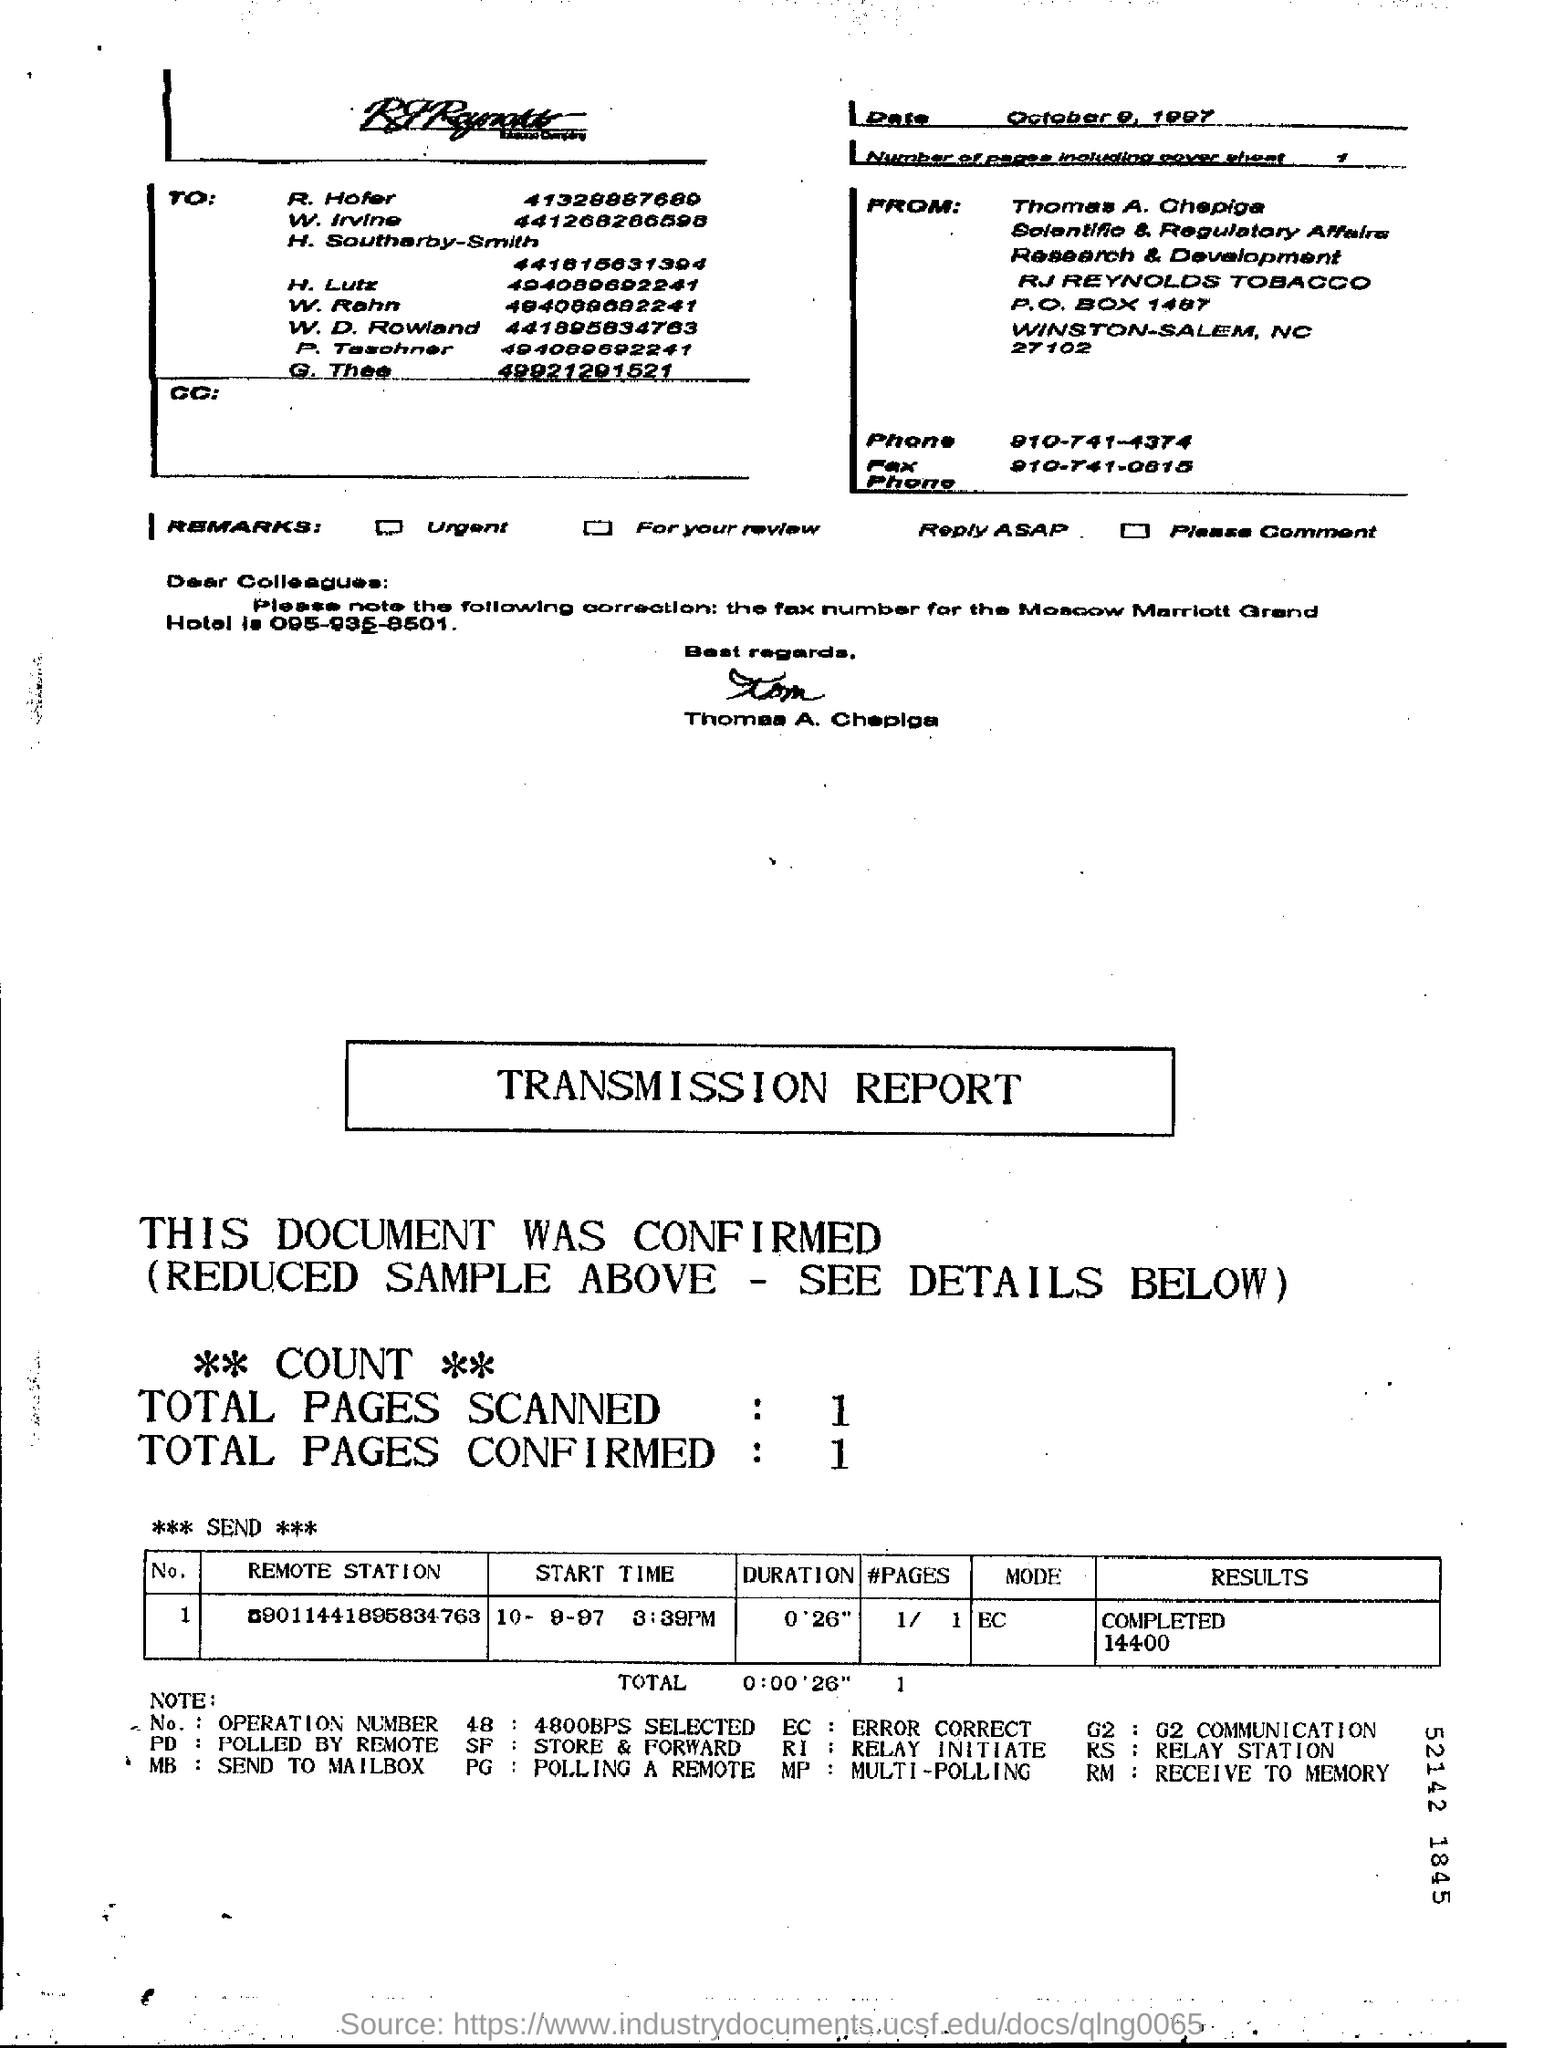Identify some key points in this picture. The total number of pages scanned is 1.. What is the duration?" is a question asking for information about the length or amount of time that something has existed or will exist. For example, "0'26" could represent the length of time it takes to complete a specific action or task. The total number of pages confirmed is 1.. 